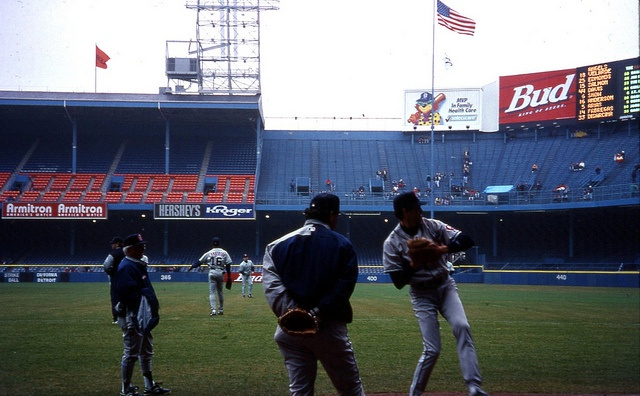Describe the objects in this image and their specific colors. I can see people in lavender, black, gray, navy, and darkgreen tones, people in lavender, black, and gray tones, people in lavender, black, navy, gray, and darkblue tones, people in lavender, black, gray, and darkgray tones, and people in lavender, black, gray, navy, and darkgreen tones in this image. 